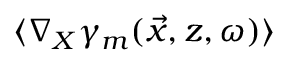Convert formula to latex. <formula><loc_0><loc_0><loc_500><loc_500>\langle \nabla _ { X } \gamma _ { m } ( \vec { x } , z , \omega ) \rangle</formula> 